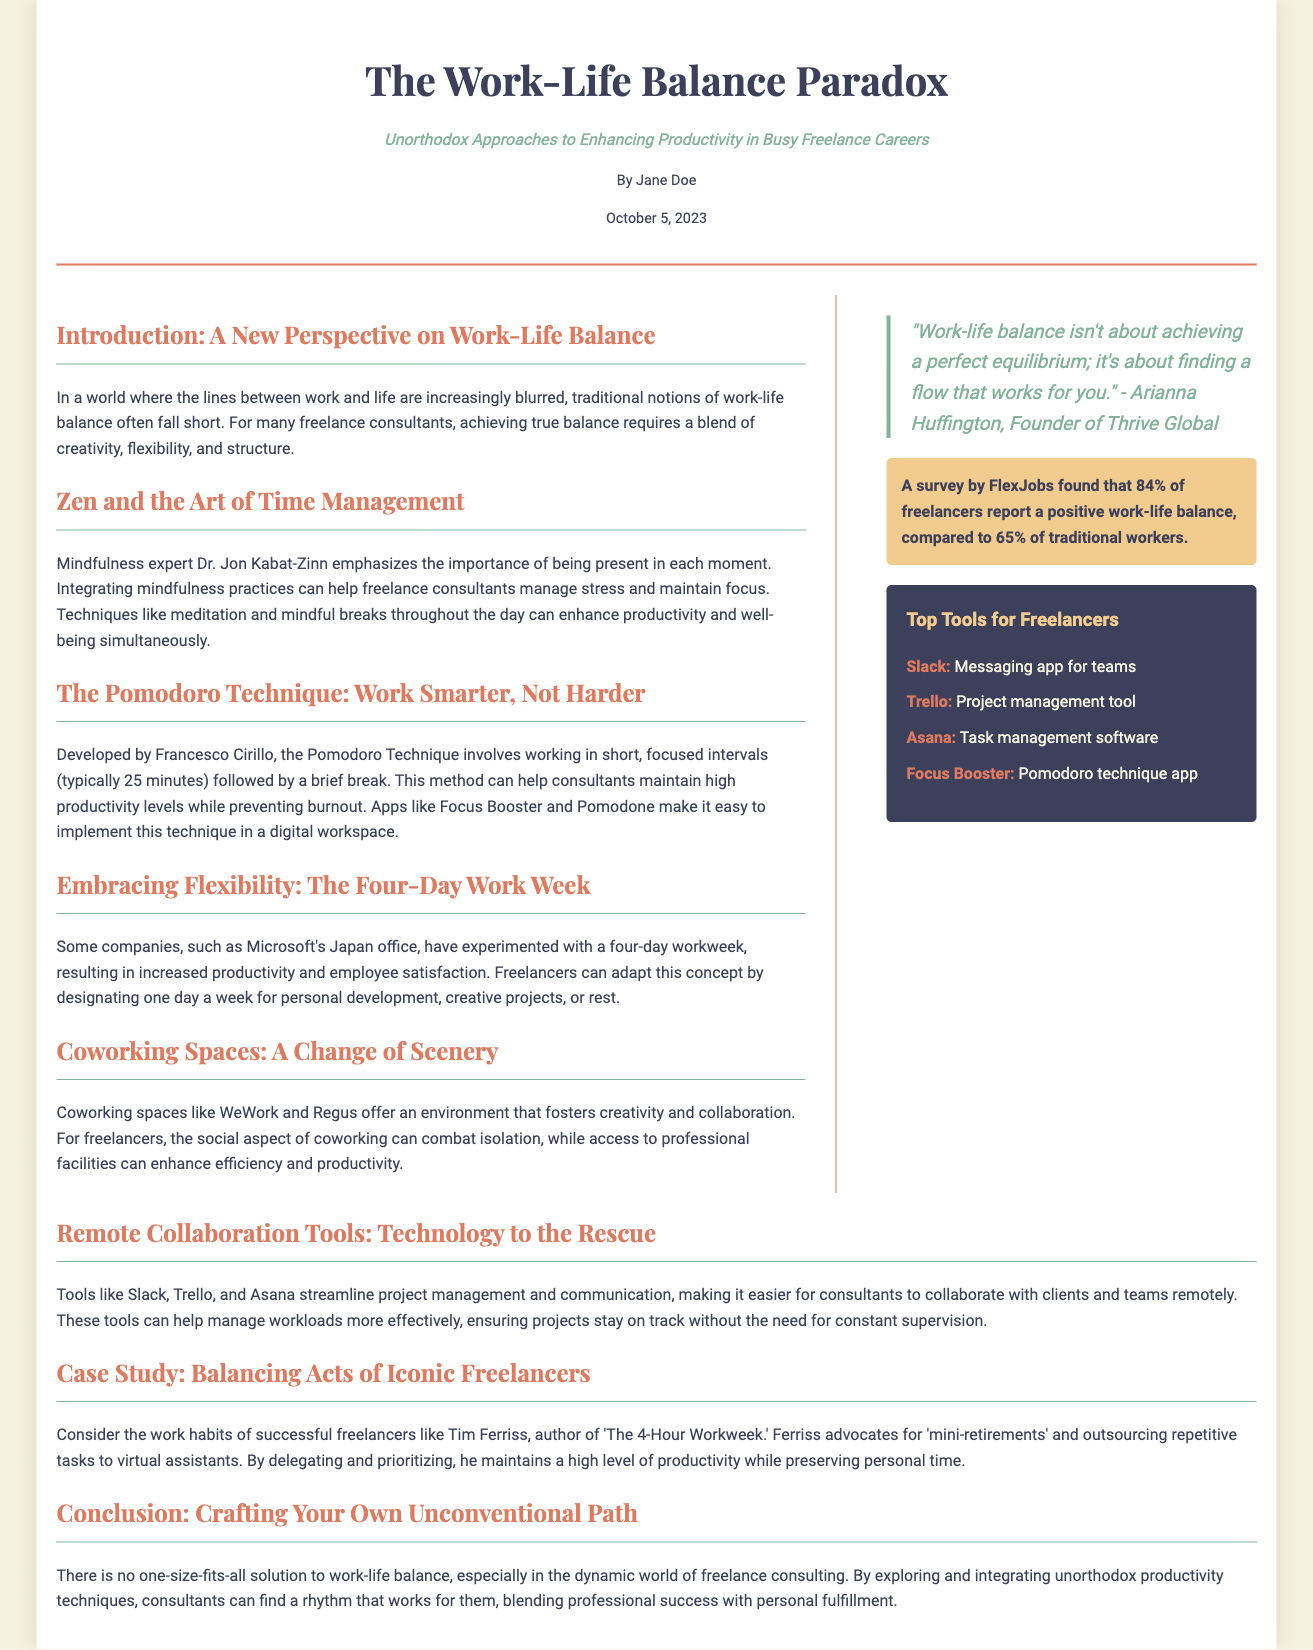What is the title of the article? The title of the article is presented prominently at the beginning of the document.
Answer: The Work-Life Balance Paradox Who is the author of the article? The author's name is stated in the header section of the document.
Answer: Jane Doe What date was the article published? The publication date is also mentioned in the header section.
Answer: October 5, 2023 What percentage of freelancers report a positive work-life balance? The specific statistic regarding freelancers is highlighted in the sidebar statistics section.
Answer: 84% What technique is advocated by Francesco Cirillo? The document describes a specific technique associated with Francesco Cirillo.
Answer: Pomodoro Technique What does the quote by Arianna Huffington emphasize? The quote discusses the concept of work-life balance and how it is perceived.
Answer: Finding a flow that works for you Which company experimented with a four-day workweek? The document provides an example of a company that tried this work arrangement.
Answer: Microsoft's Japan office Which tool is mentioned as a messaging app for teams? The sidebar lists various tools for freelancers, including one that is a messaging app.
Answer: Slack What is the focus of the case study mentioned? The document describes a particular subject related to work habits.
Answer: Balancing Acts of Iconic Freelancers 